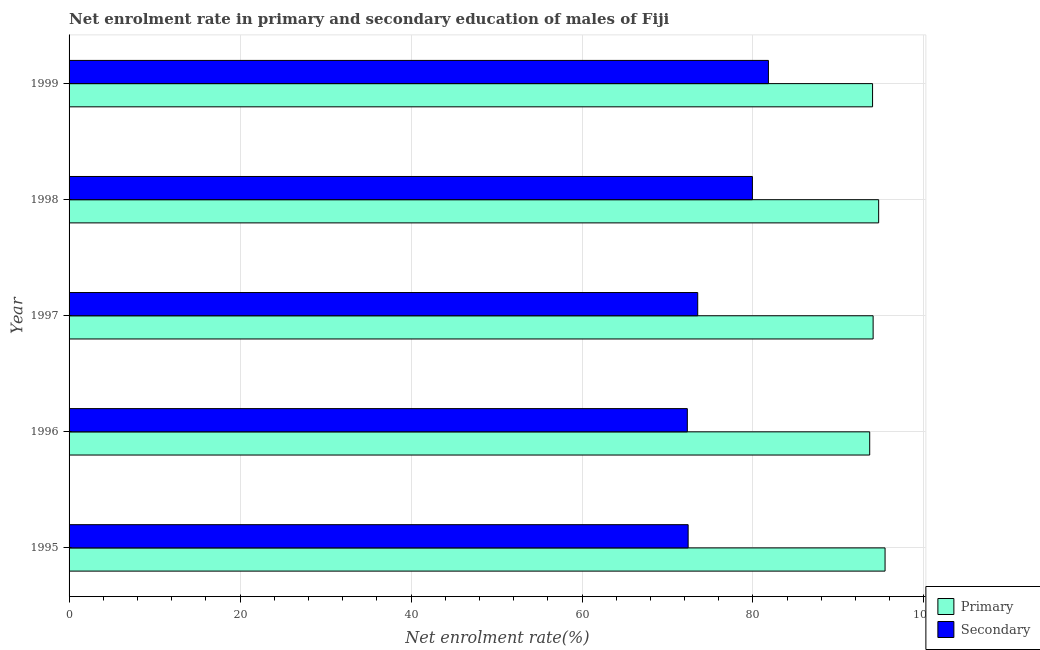How many different coloured bars are there?
Give a very brief answer. 2. How many groups of bars are there?
Offer a very short reply. 5. Are the number of bars per tick equal to the number of legend labels?
Your answer should be compact. Yes. Are the number of bars on each tick of the Y-axis equal?
Offer a very short reply. Yes. How many bars are there on the 1st tick from the bottom?
Your answer should be compact. 2. What is the enrollment rate in primary education in 1998?
Give a very brief answer. 94.7. Across all years, what is the maximum enrollment rate in primary education?
Give a very brief answer. 95.45. Across all years, what is the minimum enrollment rate in primary education?
Your response must be concise. 93.65. In which year was the enrollment rate in primary education minimum?
Your response must be concise. 1996. What is the total enrollment rate in secondary education in the graph?
Provide a succinct answer. 380.01. What is the difference between the enrollment rate in primary education in 1995 and that in 1997?
Provide a short and direct response. 1.4. What is the difference between the enrollment rate in primary education in 1998 and the enrollment rate in secondary education in 1999?
Your answer should be very brief. 12.89. What is the average enrollment rate in secondary education per year?
Your answer should be compact. 76. In the year 1997, what is the difference between the enrollment rate in primary education and enrollment rate in secondary education?
Provide a succinct answer. 20.52. Is the difference between the enrollment rate in primary education in 1996 and 1999 greater than the difference between the enrollment rate in secondary education in 1996 and 1999?
Offer a very short reply. Yes. What is the difference between the highest and the second highest enrollment rate in primary education?
Your answer should be very brief. 0.75. What is the difference between the highest and the lowest enrollment rate in secondary education?
Provide a short and direct response. 9.49. Is the sum of the enrollment rate in secondary education in 1995 and 1997 greater than the maximum enrollment rate in primary education across all years?
Give a very brief answer. Yes. What does the 2nd bar from the top in 1995 represents?
Provide a short and direct response. Primary. What does the 2nd bar from the bottom in 1997 represents?
Offer a terse response. Secondary. How many years are there in the graph?
Offer a very short reply. 5. What is the difference between two consecutive major ticks on the X-axis?
Provide a succinct answer. 20. Are the values on the major ticks of X-axis written in scientific E-notation?
Your response must be concise. No. Where does the legend appear in the graph?
Your answer should be very brief. Bottom right. How are the legend labels stacked?
Make the answer very short. Vertical. What is the title of the graph?
Your answer should be compact. Net enrolment rate in primary and secondary education of males of Fiji. Does "Pregnant women" appear as one of the legend labels in the graph?
Ensure brevity in your answer.  No. What is the label or title of the X-axis?
Your response must be concise. Net enrolment rate(%). What is the Net enrolment rate(%) in Primary in 1995?
Give a very brief answer. 95.45. What is the Net enrolment rate(%) in Secondary in 1995?
Ensure brevity in your answer.  72.42. What is the Net enrolment rate(%) of Primary in 1996?
Ensure brevity in your answer.  93.65. What is the Net enrolment rate(%) of Secondary in 1996?
Ensure brevity in your answer.  72.32. What is the Net enrolment rate(%) in Primary in 1997?
Provide a succinct answer. 94.05. What is the Net enrolment rate(%) in Secondary in 1997?
Ensure brevity in your answer.  73.54. What is the Net enrolment rate(%) of Primary in 1998?
Provide a succinct answer. 94.7. What is the Net enrolment rate(%) of Secondary in 1998?
Your answer should be compact. 79.93. What is the Net enrolment rate(%) of Primary in 1999?
Give a very brief answer. 93.99. What is the Net enrolment rate(%) in Secondary in 1999?
Provide a short and direct response. 81.81. Across all years, what is the maximum Net enrolment rate(%) of Primary?
Provide a short and direct response. 95.45. Across all years, what is the maximum Net enrolment rate(%) of Secondary?
Offer a terse response. 81.81. Across all years, what is the minimum Net enrolment rate(%) in Primary?
Provide a succinct answer. 93.65. Across all years, what is the minimum Net enrolment rate(%) in Secondary?
Your answer should be compact. 72.32. What is the total Net enrolment rate(%) of Primary in the graph?
Provide a succinct answer. 471.85. What is the total Net enrolment rate(%) of Secondary in the graph?
Keep it short and to the point. 380.01. What is the difference between the Net enrolment rate(%) in Primary in 1995 and that in 1996?
Keep it short and to the point. 1.8. What is the difference between the Net enrolment rate(%) of Secondary in 1995 and that in 1996?
Provide a short and direct response. 0.09. What is the difference between the Net enrolment rate(%) of Primary in 1995 and that in 1997?
Make the answer very short. 1.4. What is the difference between the Net enrolment rate(%) in Secondary in 1995 and that in 1997?
Give a very brief answer. -1.12. What is the difference between the Net enrolment rate(%) of Primary in 1995 and that in 1998?
Your response must be concise. 0.75. What is the difference between the Net enrolment rate(%) in Secondary in 1995 and that in 1998?
Keep it short and to the point. -7.52. What is the difference between the Net enrolment rate(%) in Primary in 1995 and that in 1999?
Your answer should be very brief. 1.46. What is the difference between the Net enrolment rate(%) in Secondary in 1995 and that in 1999?
Your answer should be very brief. -9.39. What is the difference between the Net enrolment rate(%) of Primary in 1996 and that in 1997?
Offer a terse response. -0.4. What is the difference between the Net enrolment rate(%) in Secondary in 1996 and that in 1997?
Ensure brevity in your answer.  -1.21. What is the difference between the Net enrolment rate(%) in Primary in 1996 and that in 1998?
Keep it short and to the point. -1.05. What is the difference between the Net enrolment rate(%) in Secondary in 1996 and that in 1998?
Provide a short and direct response. -7.61. What is the difference between the Net enrolment rate(%) of Primary in 1996 and that in 1999?
Provide a succinct answer. -0.34. What is the difference between the Net enrolment rate(%) in Secondary in 1996 and that in 1999?
Offer a very short reply. -9.49. What is the difference between the Net enrolment rate(%) of Primary in 1997 and that in 1998?
Provide a short and direct response. -0.65. What is the difference between the Net enrolment rate(%) in Secondary in 1997 and that in 1998?
Your answer should be very brief. -6.4. What is the difference between the Net enrolment rate(%) in Primary in 1997 and that in 1999?
Make the answer very short. 0.07. What is the difference between the Net enrolment rate(%) in Secondary in 1997 and that in 1999?
Keep it short and to the point. -8.27. What is the difference between the Net enrolment rate(%) in Primary in 1998 and that in 1999?
Your response must be concise. 0.71. What is the difference between the Net enrolment rate(%) in Secondary in 1998 and that in 1999?
Keep it short and to the point. -1.87. What is the difference between the Net enrolment rate(%) in Primary in 1995 and the Net enrolment rate(%) in Secondary in 1996?
Your response must be concise. 23.13. What is the difference between the Net enrolment rate(%) in Primary in 1995 and the Net enrolment rate(%) in Secondary in 1997?
Offer a very short reply. 21.92. What is the difference between the Net enrolment rate(%) in Primary in 1995 and the Net enrolment rate(%) in Secondary in 1998?
Provide a succinct answer. 15.52. What is the difference between the Net enrolment rate(%) of Primary in 1995 and the Net enrolment rate(%) of Secondary in 1999?
Ensure brevity in your answer.  13.64. What is the difference between the Net enrolment rate(%) of Primary in 1996 and the Net enrolment rate(%) of Secondary in 1997?
Offer a terse response. 20.12. What is the difference between the Net enrolment rate(%) in Primary in 1996 and the Net enrolment rate(%) in Secondary in 1998?
Your response must be concise. 13.72. What is the difference between the Net enrolment rate(%) of Primary in 1996 and the Net enrolment rate(%) of Secondary in 1999?
Your answer should be compact. 11.85. What is the difference between the Net enrolment rate(%) of Primary in 1997 and the Net enrolment rate(%) of Secondary in 1998?
Give a very brief answer. 14.12. What is the difference between the Net enrolment rate(%) of Primary in 1997 and the Net enrolment rate(%) of Secondary in 1999?
Give a very brief answer. 12.25. What is the difference between the Net enrolment rate(%) of Primary in 1998 and the Net enrolment rate(%) of Secondary in 1999?
Provide a succinct answer. 12.89. What is the average Net enrolment rate(%) of Primary per year?
Offer a terse response. 94.37. What is the average Net enrolment rate(%) in Secondary per year?
Make the answer very short. 76. In the year 1995, what is the difference between the Net enrolment rate(%) of Primary and Net enrolment rate(%) of Secondary?
Your response must be concise. 23.03. In the year 1996, what is the difference between the Net enrolment rate(%) in Primary and Net enrolment rate(%) in Secondary?
Provide a short and direct response. 21.33. In the year 1997, what is the difference between the Net enrolment rate(%) in Primary and Net enrolment rate(%) in Secondary?
Provide a succinct answer. 20.52. In the year 1998, what is the difference between the Net enrolment rate(%) of Primary and Net enrolment rate(%) of Secondary?
Your answer should be very brief. 14.77. In the year 1999, what is the difference between the Net enrolment rate(%) in Primary and Net enrolment rate(%) in Secondary?
Your response must be concise. 12.18. What is the ratio of the Net enrolment rate(%) in Primary in 1995 to that in 1996?
Your response must be concise. 1.02. What is the ratio of the Net enrolment rate(%) of Secondary in 1995 to that in 1996?
Provide a short and direct response. 1. What is the ratio of the Net enrolment rate(%) of Primary in 1995 to that in 1997?
Provide a short and direct response. 1.01. What is the ratio of the Net enrolment rate(%) of Secondary in 1995 to that in 1997?
Your answer should be very brief. 0.98. What is the ratio of the Net enrolment rate(%) in Primary in 1995 to that in 1998?
Your answer should be very brief. 1.01. What is the ratio of the Net enrolment rate(%) in Secondary in 1995 to that in 1998?
Your response must be concise. 0.91. What is the ratio of the Net enrolment rate(%) of Primary in 1995 to that in 1999?
Your answer should be compact. 1.02. What is the ratio of the Net enrolment rate(%) of Secondary in 1995 to that in 1999?
Provide a succinct answer. 0.89. What is the ratio of the Net enrolment rate(%) in Secondary in 1996 to that in 1997?
Your answer should be compact. 0.98. What is the ratio of the Net enrolment rate(%) in Primary in 1996 to that in 1998?
Provide a short and direct response. 0.99. What is the ratio of the Net enrolment rate(%) of Secondary in 1996 to that in 1998?
Your answer should be very brief. 0.9. What is the ratio of the Net enrolment rate(%) of Secondary in 1996 to that in 1999?
Your answer should be very brief. 0.88. What is the ratio of the Net enrolment rate(%) in Primary in 1997 to that in 1998?
Offer a very short reply. 0.99. What is the ratio of the Net enrolment rate(%) of Primary in 1997 to that in 1999?
Your answer should be compact. 1. What is the ratio of the Net enrolment rate(%) in Secondary in 1997 to that in 1999?
Offer a terse response. 0.9. What is the ratio of the Net enrolment rate(%) in Primary in 1998 to that in 1999?
Your answer should be compact. 1.01. What is the ratio of the Net enrolment rate(%) in Secondary in 1998 to that in 1999?
Ensure brevity in your answer.  0.98. What is the difference between the highest and the second highest Net enrolment rate(%) in Primary?
Provide a succinct answer. 0.75. What is the difference between the highest and the second highest Net enrolment rate(%) of Secondary?
Offer a terse response. 1.87. What is the difference between the highest and the lowest Net enrolment rate(%) of Primary?
Keep it short and to the point. 1.8. What is the difference between the highest and the lowest Net enrolment rate(%) of Secondary?
Ensure brevity in your answer.  9.49. 